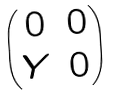Convert formula to latex. <formula><loc_0><loc_0><loc_500><loc_500>\begin{pmatrix} 0 & 0 \\ Y & 0 \end{pmatrix}</formula> 